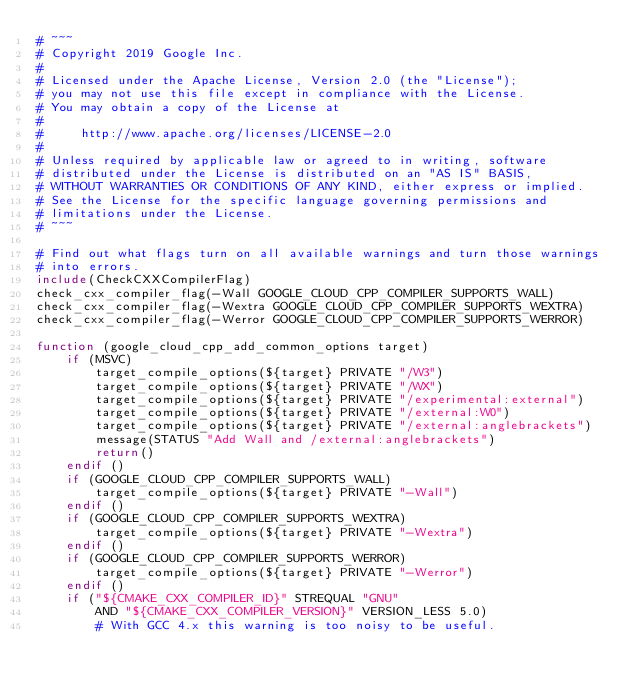Convert code to text. <code><loc_0><loc_0><loc_500><loc_500><_CMake_># ~~~
# Copyright 2019 Google Inc.
#
# Licensed under the Apache License, Version 2.0 (the "License");
# you may not use this file except in compliance with the License.
# You may obtain a copy of the License at
#
#     http://www.apache.org/licenses/LICENSE-2.0
#
# Unless required by applicable law or agreed to in writing, software
# distributed under the License is distributed on an "AS IS" BASIS,
# WITHOUT WARRANTIES OR CONDITIONS OF ANY KIND, either express or implied.
# See the License for the specific language governing permissions and
# limitations under the License.
# ~~~

# Find out what flags turn on all available warnings and turn those warnings
# into errors.
include(CheckCXXCompilerFlag)
check_cxx_compiler_flag(-Wall GOOGLE_CLOUD_CPP_COMPILER_SUPPORTS_WALL)
check_cxx_compiler_flag(-Wextra GOOGLE_CLOUD_CPP_COMPILER_SUPPORTS_WEXTRA)
check_cxx_compiler_flag(-Werror GOOGLE_CLOUD_CPP_COMPILER_SUPPORTS_WERROR)

function (google_cloud_cpp_add_common_options target)
    if (MSVC)
        target_compile_options(${target} PRIVATE "/W3")
        target_compile_options(${target} PRIVATE "/WX")
        target_compile_options(${target} PRIVATE "/experimental:external")
        target_compile_options(${target} PRIVATE "/external:W0")
        target_compile_options(${target} PRIVATE "/external:anglebrackets")
        message(STATUS "Add Wall and /external:anglebrackets")
        return()
    endif ()
    if (GOOGLE_CLOUD_CPP_COMPILER_SUPPORTS_WALL)
        target_compile_options(${target} PRIVATE "-Wall")
    endif ()
    if (GOOGLE_CLOUD_CPP_COMPILER_SUPPORTS_WEXTRA)
        target_compile_options(${target} PRIVATE "-Wextra")
    endif ()
    if (GOOGLE_CLOUD_CPP_COMPILER_SUPPORTS_WERROR)
        target_compile_options(${target} PRIVATE "-Werror")
    endif ()
    if ("${CMAKE_CXX_COMPILER_ID}" STREQUAL "GNU"
        AND "${CMAKE_CXX_COMPILER_VERSION}" VERSION_LESS 5.0)
        # With GCC 4.x this warning is too noisy to be useful.</code> 